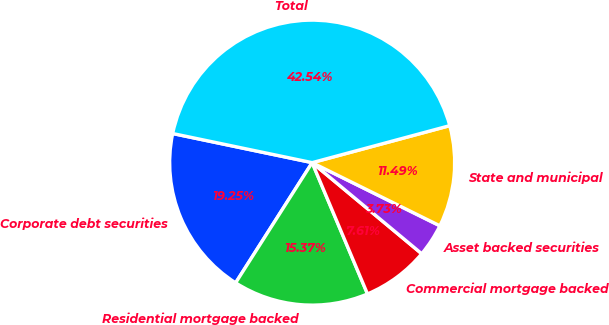Convert chart. <chart><loc_0><loc_0><loc_500><loc_500><pie_chart><fcel>Corporate debt securities<fcel>Residential mortgage backed<fcel>Commercial mortgage backed<fcel>Asset backed securities<fcel>State and municipal<fcel>Total<nl><fcel>19.25%<fcel>15.37%<fcel>7.61%<fcel>3.73%<fcel>11.49%<fcel>42.54%<nl></chart> 